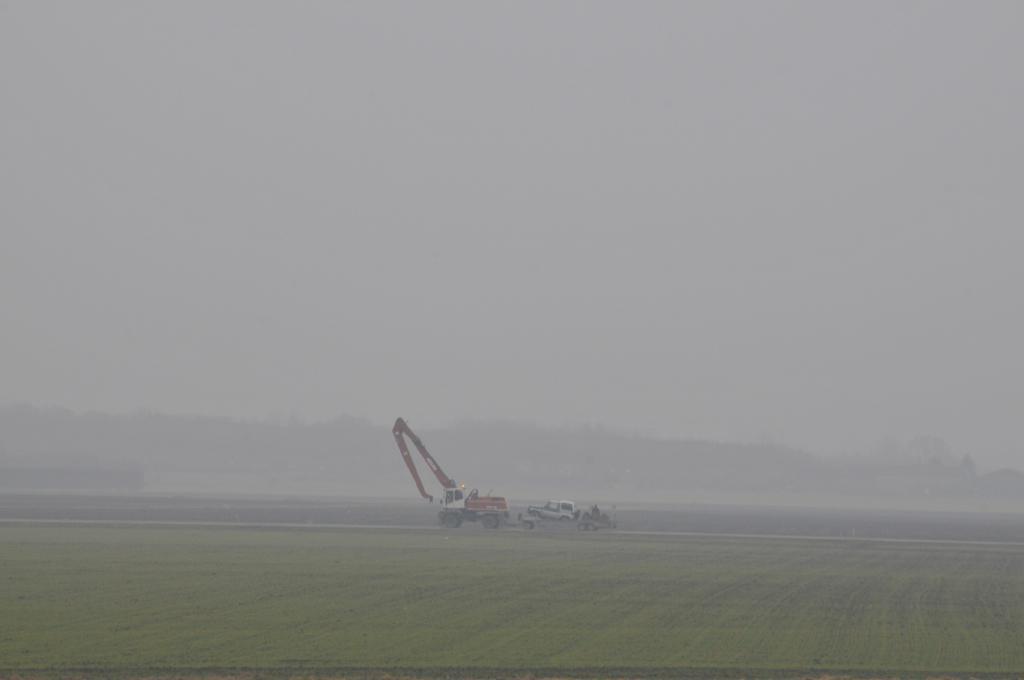Please provide a concise description of this image. In this image in the front there's grass on the ground. In the center there are vehicles. In the background there are trees and the sky is cloudy and there is smoke. 